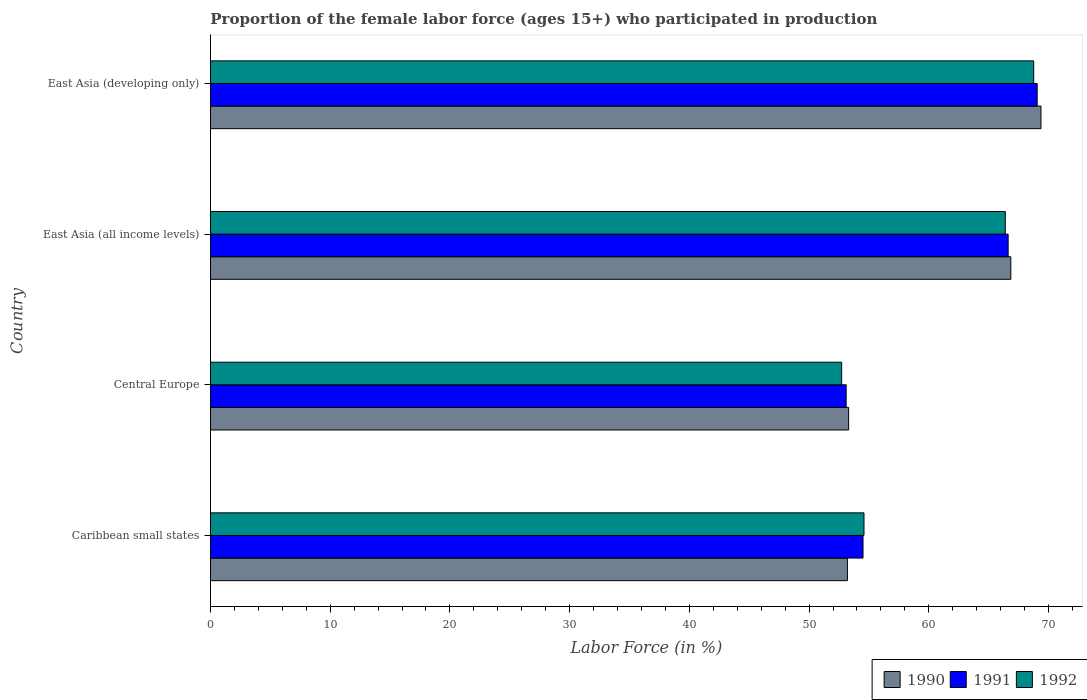How many different coloured bars are there?
Offer a very short reply. 3. How many groups of bars are there?
Provide a short and direct response. 4. Are the number of bars on each tick of the Y-axis equal?
Offer a very short reply. Yes. How many bars are there on the 2nd tick from the bottom?
Your answer should be very brief. 3. What is the label of the 2nd group of bars from the top?
Offer a terse response. East Asia (all income levels). What is the proportion of the female labor force who participated in production in 1991 in Central Europe?
Ensure brevity in your answer.  53.1. Across all countries, what is the maximum proportion of the female labor force who participated in production in 1991?
Your response must be concise. 69.06. Across all countries, what is the minimum proportion of the female labor force who participated in production in 1990?
Provide a short and direct response. 53.2. In which country was the proportion of the female labor force who participated in production in 1991 maximum?
Provide a short and direct response. East Asia (developing only). In which country was the proportion of the female labor force who participated in production in 1992 minimum?
Ensure brevity in your answer.  Central Europe. What is the total proportion of the female labor force who participated in production in 1990 in the graph?
Your answer should be compact. 242.73. What is the difference between the proportion of the female labor force who participated in production in 1992 in Caribbean small states and that in East Asia (developing only)?
Ensure brevity in your answer.  -14.18. What is the difference between the proportion of the female labor force who participated in production in 1992 in East Asia (all income levels) and the proportion of the female labor force who participated in production in 1990 in East Asia (developing only)?
Offer a terse response. -2.98. What is the average proportion of the female labor force who participated in production in 1991 per country?
Offer a terse response. 60.82. What is the difference between the proportion of the female labor force who participated in production in 1991 and proportion of the female labor force who participated in production in 1990 in Caribbean small states?
Your answer should be compact. 1.3. In how many countries, is the proportion of the female labor force who participated in production in 1990 greater than 50 %?
Your response must be concise. 4. What is the ratio of the proportion of the female labor force who participated in production in 1992 in Caribbean small states to that in Central Europe?
Ensure brevity in your answer.  1.04. Is the proportion of the female labor force who participated in production in 1992 in Caribbean small states less than that in Central Europe?
Offer a terse response. No. Is the difference between the proportion of the female labor force who participated in production in 1991 in East Asia (all income levels) and East Asia (developing only) greater than the difference between the proportion of the female labor force who participated in production in 1990 in East Asia (all income levels) and East Asia (developing only)?
Ensure brevity in your answer.  Yes. What is the difference between the highest and the second highest proportion of the female labor force who participated in production in 1990?
Provide a short and direct response. 2.52. What is the difference between the highest and the lowest proportion of the female labor force who participated in production in 1992?
Keep it short and to the point. 16.04. Is the sum of the proportion of the female labor force who participated in production in 1990 in Caribbean small states and Central Europe greater than the maximum proportion of the female labor force who participated in production in 1992 across all countries?
Your response must be concise. Yes. What does the 3rd bar from the bottom in East Asia (all income levels) represents?
Offer a terse response. 1992. Are all the bars in the graph horizontal?
Make the answer very short. Yes. How many countries are there in the graph?
Ensure brevity in your answer.  4. What is the difference between two consecutive major ticks on the X-axis?
Keep it short and to the point. 10. Does the graph contain any zero values?
Keep it short and to the point. No. Where does the legend appear in the graph?
Offer a very short reply. Bottom right. What is the title of the graph?
Your response must be concise. Proportion of the female labor force (ages 15+) who participated in production. What is the label or title of the X-axis?
Offer a terse response. Labor Force (in %). What is the label or title of the Y-axis?
Offer a terse response. Country. What is the Labor Force (in %) in 1990 in Caribbean small states?
Ensure brevity in your answer.  53.2. What is the Labor Force (in %) of 1991 in Caribbean small states?
Provide a succinct answer. 54.51. What is the Labor Force (in %) of 1992 in Caribbean small states?
Ensure brevity in your answer.  54.59. What is the Labor Force (in %) of 1990 in Central Europe?
Give a very brief answer. 53.31. What is the Labor Force (in %) of 1991 in Central Europe?
Offer a terse response. 53.1. What is the Labor Force (in %) of 1992 in Central Europe?
Your response must be concise. 52.72. What is the Labor Force (in %) in 1990 in East Asia (all income levels)?
Give a very brief answer. 66.85. What is the Labor Force (in %) of 1991 in East Asia (all income levels)?
Your response must be concise. 66.63. What is the Labor Force (in %) in 1992 in East Asia (all income levels)?
Offer a very short reply. 66.39. What is the Labor Force (in %) of 1990 in East Asia (developing only)?
Your answer should be very brief. 69.37. What is the Labor Force (in %) in 1991 in East Asia (developing only)?
Make the answer very short. 69.06. What is the Labor Force (in %) in 1992 in East Asia (developing only)?
Keep it short and to the point. 68.77. Across all countries, what is the maximum Labor Force (in %) of 1990?
Offer a terse response. 69.37. Across all countries, what is the maximum Labor Force (in %) of 1991?
Ensure brevity in your answer.  69.06. Across all countries, what is the maximum Labor Force (in %) of 1992?
Your answer should be compact. 68.77. Across all countries, what is the minimum Labor Force (in %) of 1990?
Offer a very short reply. 53.2. Across all countries, what is the minimum Labor Force (in %) of 1991?
Make the answer very short. 53.1. Across all countries, what is the minimum Labor Force (in %) in 1992?
Your answer should be compact. 52.72. What is the total Labor Force (in %) in 1990 in the graph?
Your response must be concise. 242.73. What is the total Labor Force (in %) of 1991 in the graph?
Your answer should be very brief. 243.29. What is the total Labor Force (in %) in 1992 in the graph?
Offer a terse response. 242.47. What is the difference between the Labor Force (in %) in 1990 in Caribbean small states and that in Central Europe?
Provide a short and direct response. -0.1. What is the difference between the Labor Force (in %) of 1991 in Caribbean small states and that in Central Europe?
Offer a very short reply. 1.41. What is the difference between the Labor Force (in %) of 1992 in Caribbean small states and that in Central Europe?
Give a very brief answer. 1.87. What is the difference between the Labor Force (in %) of 1990 in Caribbean small states and that in East Asia (all income levels)?
Offer a terse response. -13.65. What is the difference between the Labor Force (in %) of 1991 in Caribbean small states and that in East Asia (all income levels)?
Provide a short and direct response. -12.12. What is the difference between the Labor Force (in %) in 1992 in Caribbean small states and that in East Asia (all income levels)?
Provide a succinct answer. -11.8. What is the difference between the Labor Force (in %) in 1990 in Caribbean small states and that in East Asia (developing only)?
Your answer should be compact. -16.17. What is the difference between the Labor Force (in %) in 1991 in Caribbean small states and that in East Asia (developing only)?
Offer a terse response. -14.55. What is the difference between the Labor Force (in %) in 1992 in Caribbean small states and that in East Asia (developing only)?
Your answer should be very brief. -14.18. What is the difference between the Labor Force (in %) of 1990 in Central Europe and that in East Asia (all income levels)?
Offer a very short reply. -13.55. What is the difference between the Labor Force (in %) in 1991 in Central Europe and that in East Asia (all income levels)?
Give a very brief answer. -13.53. What is the difference between the Labor Force (in %) in 1992 in Central Europe and that in East Asia (all income levels)?
Provide a short and direct response. -13.67. What is the difference between the Labor Force (in %) of 1990 in Central Europe and that in East Asia (developing only)?
Your answer should be compact. -16.07. What is the difference between the Labor Force (in %) in 1991 in Central Europe and that in East Asia (developing only)?
Ensure brevity in your answer.  -15.95. What is the difference between the Labor Force (in %) in 1992 in Central Europe and that in East Asia (developing only)?
Offer a very short reply. -16.04. What is the difference between the Labor Force (in %) of 1990 in East Asia (all income levels) and that in East Asia (developing only)?
Offer a very short reply. -2.52. What is the difference between the Labor Force (in %) in 1991 in East Asia (all income levels) and that in East Asia (developing only)?
Give a very brief answer. -2.43. What is the difference between the Labor Force (in %) in 1992 in East Asia (all income levels) and that in East Asia (developing only)?
Offer a very short reply. -2.37. What is the difference between the Labor Force (in %) of 1990 in Caribbean small states and the Labor Force (in %) of 1991 in Central Europe?
Ensure brevity in your answer.  0.1. What is the difference between the Labor Force (in %) in 1990 in Caribbean small states and the Labor Force (in %) in 1992 in Central Europe?
Provide a short and direct response. 0.48. What is the difference between the Labor Force (in %) in 1991 in Caribbean small states and the Labor Force (in %) in 1992 in Central Europe?
Ensure brevity in your answer.  1.79. What is the difference between the Labor Force (in %) in 1990 in Caribbean small states and the Labor Force (in %) in 1991 in East Asia (all income levels)?
Provide a short and direct response. -13.43. What is the difference between the Labor Force (in %) of 1990 in Caribbean small states and the Labor Force (in %) of 1992 in East Asia (all income levels)?
Offer a terse response. -13.19. What is the difference between the Labor Force (in %) in 1991 in Caribbean small states and the Labor Force (in %) in 1992 in East Asia (all income levels)?
Give a very brief answer. -11.88. What is the difference between the Labor Force (in %) of 1990 in Caribbean small states and the Labor Force (in %) of 1991 in East Asia (developing only)?
Ensure brevity in your answer.  -15.85. What is the difference between the Labor Force (in %) in 1990 in Caribbean small states and the Labor Force (in %) in 1992 in East Asia (developing only)?
Offer a very short reply. -15.56. What is the difference between the Labor Force (in %) of 1991 in Caribbean small states and the Labor Force (in %) of 1992 in East Asia (developing only)?
Keep it short and to the point. -14.26. What is the difference between the Labor Force (in %) of 1990 in Central Europe and the Labor Force (in %) of 1991 in East Asia (all income levels)?
Offer a very short reply. -13.32. What is the difference between the Labor Force (in %) of 1990 in Central Europe and the Labor Force (in %) of 1992 in East Asia (all income levels)?
Offer a very short reply. -13.09. What is the difference between the Labor Force (in %) in 1991 in Central Europe and the Labor Force (in %) in 1992 in East Asia (all income levels)?
Offer a very short reply. -13.29. What is the difference between the Labor Force (in %) of 1990 in Central Europe and the Labor Force (in %) of 1991 in East Asia (developing only)?
Ensure brevity in your answer.  -15.75. What is the difference between the Labor Force (in %) of 1990 in Central Europe and the Labor Force (in %) of 1992 in East Asia (developing only)?
Offer a very short reply. -15.46. What is the difference between the Labor Force (in %) in 1991 in Central Europe and the Labor Force (in %) in 1992 in East Asia (developing only)?
Keep it short and to the point. -15.67. What is the difference between the Labor Force (in %) of 1990 in East Asia (all income levels) and the Labor Force (in %) of 1991 in East Asia (developing only)?
Make the answer very short. -2.2. What is the difference between the Labor Force (in %) of 1990 in East Asia (all income levels) and the Labor Force (in %) of 1992 in East Asia (developing only)?
Provide a succinct answer. -1.91. What is the difference between the Labor Force (in %) of 1991 in East Asia (all income levels) and the Labor Force (in %) of 1992 in East Asia (developing only)?
Offer a very short reply. -2.14. What is the average Labor Force (in %) in 1990 per country?
Your answer should be very brief. 60.68. What is the average Labor Force (in %) in 1991 per country?
Make the answer very short. 60.82. What is the average Labor Force (in %) of 1992 per country?
Your answer should be compact. 60.62. What is the difference between the Labor Force (in %) of 1990 and Labor Force (in %) of 1991 in Caribbean small states?
Make the answer very short. -1.3. What is the difference between the Labor Force (in %) of 1990 and Labor Force (in %) of 1992 in Caribbean small states?
Keep it short and to the point. -1.38. What is the difference between the Labor Force (in %) in 1991 and Labor Force (in %) in 1992 in Caribbean small states?
Make the answer very short. -0.08. What is the difference between the Labor Force (in %) of 1990 and Labor Force (in %) of 1991 in Central Europe?
Make the answer very short. 0.2. What is the difference between the Labor Force (in %) in 1990 and Labor Force (in %) in 1992 in Central Europe?
Offer a terse response. 0.58. What is the difference between the Labor Force (in %) of 1991 and Labor Force (in %) of 1992 in Central Europe?
Keep it short and to the point. 0.38. What is the difference between the Labor Force (in %) in 1990 and Labor Force (in %) in 1991 in East Asia (all income levels)?
Give a very brief answer. 0.22. What is the difference between the Labor Force (in %) in 1990 and Labor Force (in %) in 1992 in East Asia (all income levels)?
Offer a terse response. 0.46. What is the difference between the Labor Force (in %) of 1991 and Labor Force (in %) of 1992 in East Asia (all income levels)?
Keep it short and to the point. 0.24. What is the difference between the Labor Force (in %) in 1990 and Labor Force (in %) in 1991 in East Asia (developing only)?
Ensure brevity in your answer.  0.32. What is the difference between the Labor Force (in %) in 1990 and Labor Force (in %) in 1992 in East Asia (developing only)?
Keep it short and to the point. 0.61. What is the difference between the Labor Force (in %) in 1991 and Labor Force (in %) in 1992 in East Asia (developing only)?
Provide a short and direct response. 0.29. What is the ratio of the Labor Force (in %) of 1991 in Caribbean small states to that in Central Europe?
Provide a succinct answer. 1.03. What is the ratio of the Labor Force (in %) in 1992 in Caribbean small states to that in Central Europe?
Provide a succinct answer. 1.04. What is the ratio of the Labor Force (in %) of 1990 in Caribbean small states to that in East Asia (all income levels)?
Offer a very short reply. 0.8. What is the ratio of the Labor Force (in %) in 1991 in Caribbean small states to that in East Asia (all income levels)?
Your answer should be very brief. 0.82. What is the ratio of the Labor Force (in %) in 1992 in Caribbean small states to that in East Asia (all income levels)?
Ensure brevity in your answer.  0.82. What is the ratio of the Labor Force (in %) in 1990 in Caribbean small states to that in East Asia (developing only)?
Offer a very short reply. 0.77. What is the ratio of the Labor Force (in %) of 1991 in Caribbean small states to that in East Asia (developing only)?
Your answer should be compact. 0.79. What is the ratio of the Labor Force (in %) in 1992 in Caribbean small states to that in East Asia (developing only)?
Provide a short and direct response. 0.79. What is the ratio of the Labor Force (in %) in 1990 in Central Europe to that in East Asia (all income levels)?
Offer a terse response. 0.8. What is the ratio of the Labor Force (in %) of 1991 in Central Europe to that in East Asia (all income levels)?
Provide a short and direct response. 0.8. What is the ratio of the Labor Force (in %) of 1992 in Central Europe to that in East Asia (all income levels)?
Your response must be concise. 0.79. What is the ratio of the Labor Force (in %) in 1990 in Central Europe to that in East Asia (developing only)?
Your answer should be very brief. 0.77. What is the ratio of the Labor Force (in %) in 1991 in Central Europe to that in East Asia (developing only)?
Ensure brevity in your answer.  0.77. What is the ratio of the Labor Force (in %) of 1992 in Central Europe to that in East Asia (developing only)?
Your answer should be very brief. 0.77. What is the ratio of the Labor Force (in %) of 1990 in East Asia (all income levels) to that in East Asia (developing only)?
Provide a short and direct response. 0.96. What is the ratio of the Labor Force (in %) in 1991 in East Asia (all income levels) to that in East Asia (developing only)?
Ensure brevity in your answer.  0.96. What is the ratio of the Labor Force (in %) of 1992 in East Asia (all income levels) to that in East Asia (developing only)?
Offer a terse response. 0.97. What is the difference between the highest and the second highest Labor Force (in %) of 1990?
Make the answer very short. 2.52. What is the difference between the highest and the second highest Labor Force (in %) in 1991?
Keep it short and to the point. 2.43. What is the difference between the highest and the second highest Labor Force (in %) in 1992?
Your answer should be compact. 2.37. What is the difference between the highest and the lowest Labor Force (in %) of 1990?
Make the answer very short. 16.17. What is the difference between the highest and the lowest Labor Force (in %) in 1991?
Provide a short and direct response. 15.95. What is the difference between the highest and the lowest Labor Force (in %) in 1992?
Offer a terse response. 16.04. 